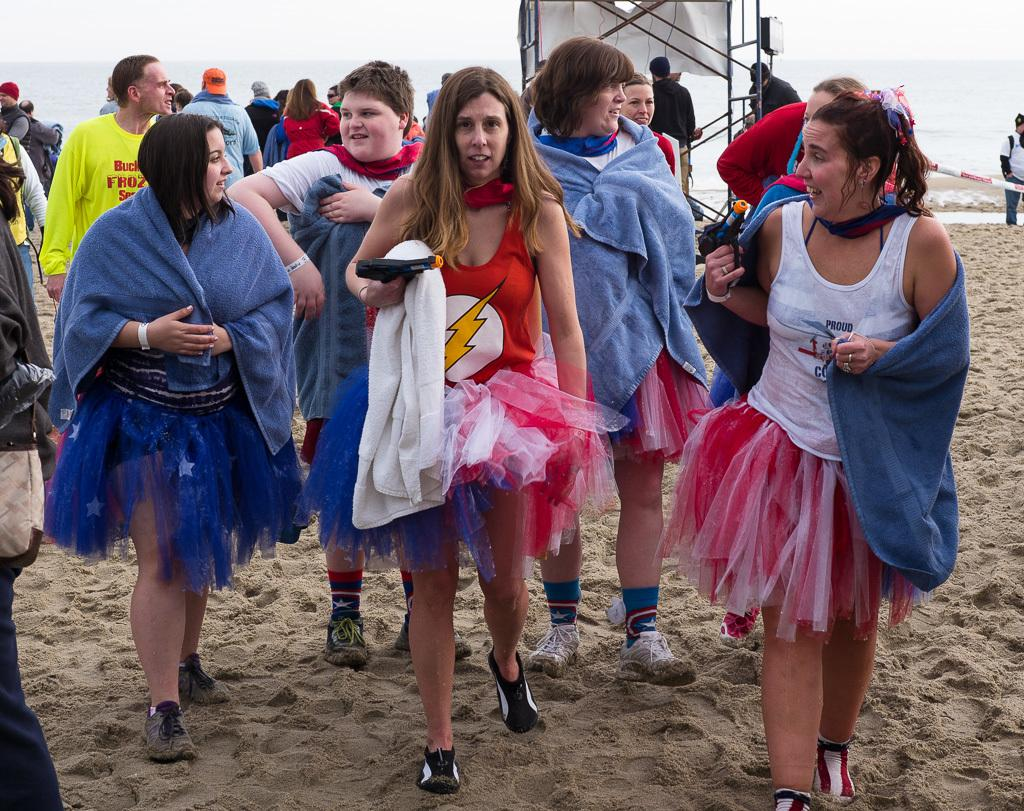How many people are in the image? There is a group of people in the image. What are the people in the image doing? Some people are standing, while others are walking. What can be seen in the background of the image? There are metal rods and water visible in the background of the image. What type of page can be seen in the image? There is no page present in the image. Is there a hospital visible in the image? There is no hospital visible in the image. 